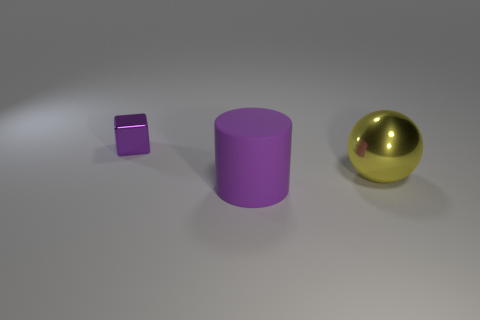Add 1 large brown metallic blocks. How many objects exist? 4 Subtract all green balls. How many green cylinders are left? 0 Subtract all blocks. How many objects are left? 2 Subtract all blue shiny objects. Subtract all big purple things. How many objects are left? 2 Add 2 cylinders. How many cylinders are left? 3 Add 1 tiny purple shiny cubes. How many tiny purple shiny cubes exist? 2 Subtract 0 brown blocks. How many objects are left? 3 